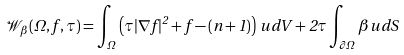Convert formula to latex. <formula><loc_0><loc_0><loc_500><loc_500>\mathcal { W } _ { \beta } ( \Omega , f , \tau ) = \int _ { \Omega } \left ( \tau | \nabla f | ^ { 2 } + f - ( n + 1 ) \right ) \, u \, d V + 2 \tau \int _ { \partial \Omega } \beta u \, d S</formula> 